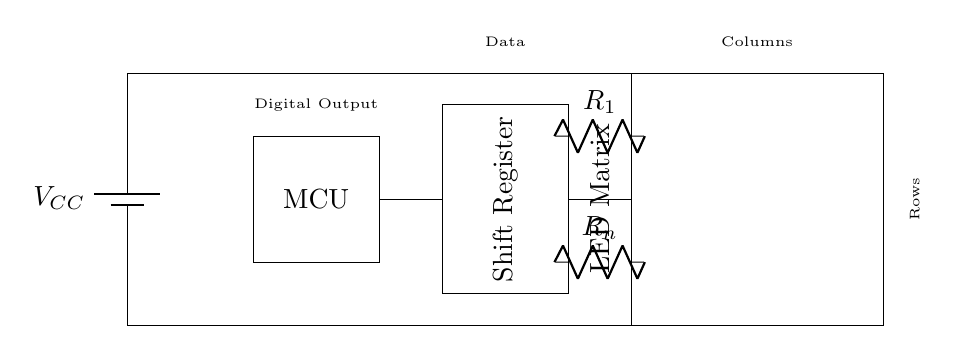What is the primary role of the microcontroller in this circuit? The microcontroller is responsible for controlling the operation of the shift register, managing the digital outputs that drive the LED matrix.
Answer: Control What type of components are used to limit current to the LEDs? The components used for current limiting are resistors which ensure that the LEDs operate within safe current levels.
Answer: Resistors How many outputs does the shift register have? The shift register typically has multiple outputs corresponding to the number of columns in the LED matrix, which is implied by the standard operation of such devices.
Answer: Multiple What does R_n represent in this diagram? R_n indicates a current-limiting resistor connected to one of the rows of the LED matrix, which helps prevent excess current that could damage the LED.
Answer: Current-limiting resistor Which component is directly connected to the battery? The power supply, represented by the battery symbol, is directly connected to the circuit to provide voltage to all components.
Answer: Battery What does the term "MCU" stand for in this circuit? MCU stands for Microcontroller Unit, which is a key component that processes the input data and controls the display of scores on the LED matrix.
Answer: Microcontroller Unit How are the columns of the LED matrix controlled? The columns of the LED matrix are controlled through the outputs of the shift register, which receive data from the microcontroller and activate the corresponding columns of LEDs.
Answer: Shift register outputs 